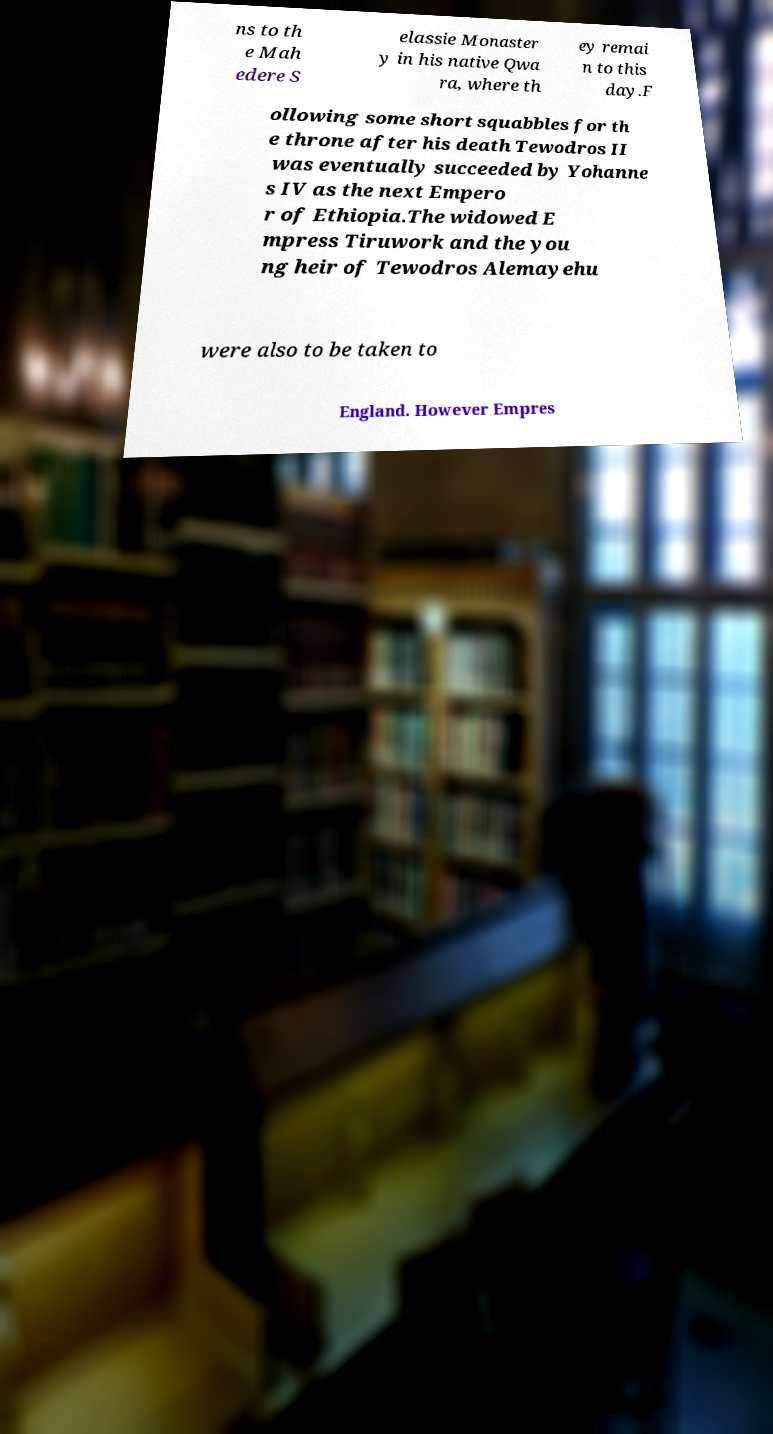Can you read and provide the text displayed in the image?This photo seems to have some interesting text. Can you extract and type it out for me? ns to th e Mah edere S elassie Monaster y in his native Qwa ra, where th ey remai n to this day.F ollowing some short squabbles for th e throne after his death Tewodros II was eventually succeeded by Yohanne s IV as the next Empero r of Ethiopia.The widowed E mpress Tiruwork and the you ng heir of Tewodros Alemayehu were also to be taken to England. However Empres 